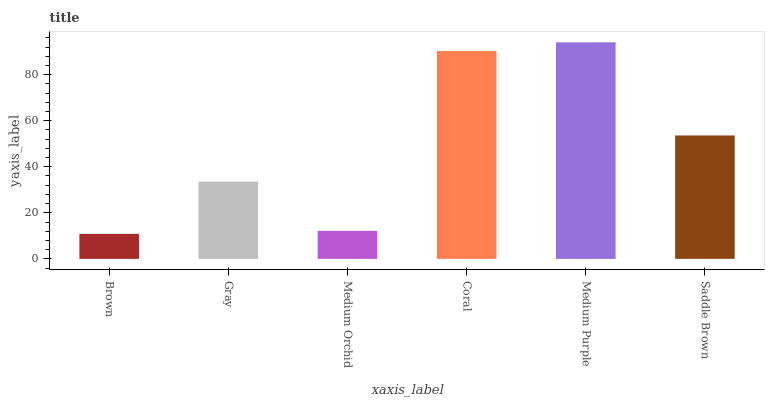Is Gray the minimum?
Answer yes or no. No. Is Gray the maximum?
Answer yes or no. No. Is Gray greater than Brown?
Answer yes or no. Yes. Is Brown less than Gray?
Answer yes or no. Yes. Is Brown greater than Gray?
Answer yes or no. No. Is Gray less than Brown?
Answer yes or no. No. Is Saddle Brown the high median?
Answer yes or no. Yes. Is Gray the low median?
Answer yes or no. Yes. Is Gray the high median?
Answer yes or no. No. Is Medium Orchid the low median?
Answer yes or no. No. 